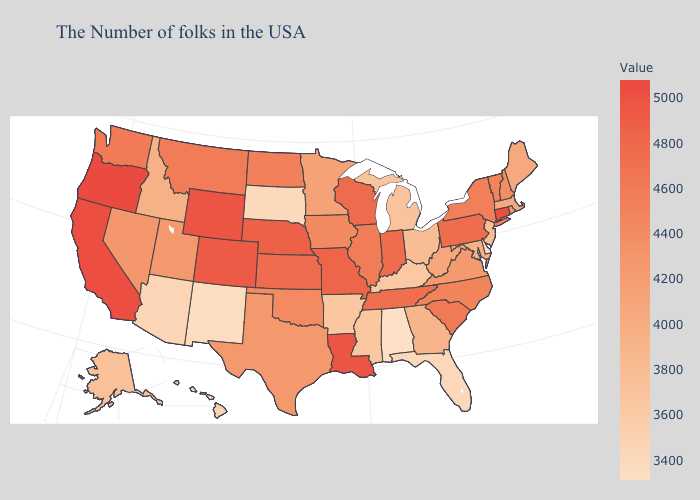Among the states that border South Carolina , which have the highest value?
Concise answer only. North Carolina. Among the states that border Mississippi , does Tennessee have the lowest value?
Write a very short answer. No. Among the states that border Alabama , which have the lowest value?
Write a very short answer. Florida. Which states hav the highest value in the West?
Short answer required. Oregon. Does Oklahoma have the lowest value in the South?
Quick response, please. No. Does Montana have the lowest value in the West?
Give a very brief answer. No. Does North Dakota have the highest value in the USA?
Write a very short answer. No. Does Rhode Island have a higher value than Oregon?
Concise answer only. No. Which states have the lowest value in the USA?
Keep it brief. Alabama. 